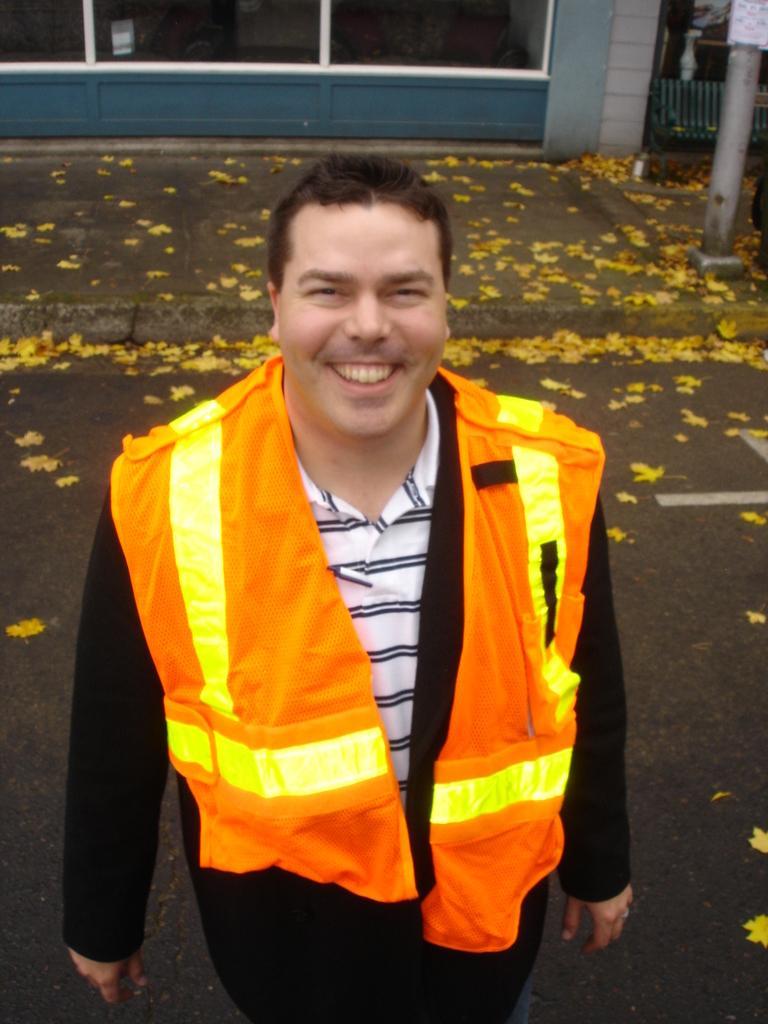Could you give a brief overview of what you see in this image? In this image we can see a person wearing a jacket. On the ground there are leaves. In the back there is a pole. And there is a building. 